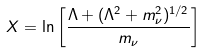<formula> <loc_0><loc_0><loc_500><loc_500>X = \ln \left [ \frac { \Lambda + ( \Lambda ^ { 2 } + m _ { \nu } ^ { 2 } ) ^ { 1 / 2 } } { m _ { \nu } } \right ]</formula> 